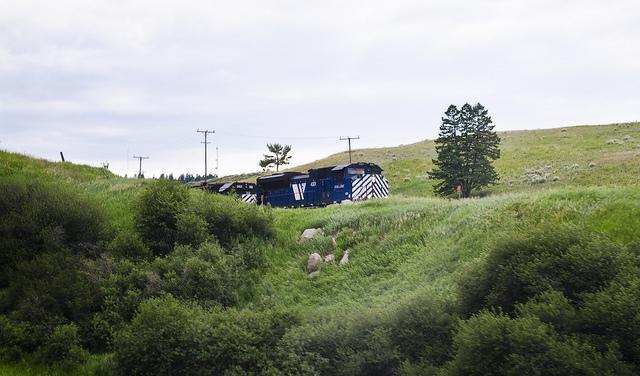How many boulders?
Give a very brief answer. 4. 